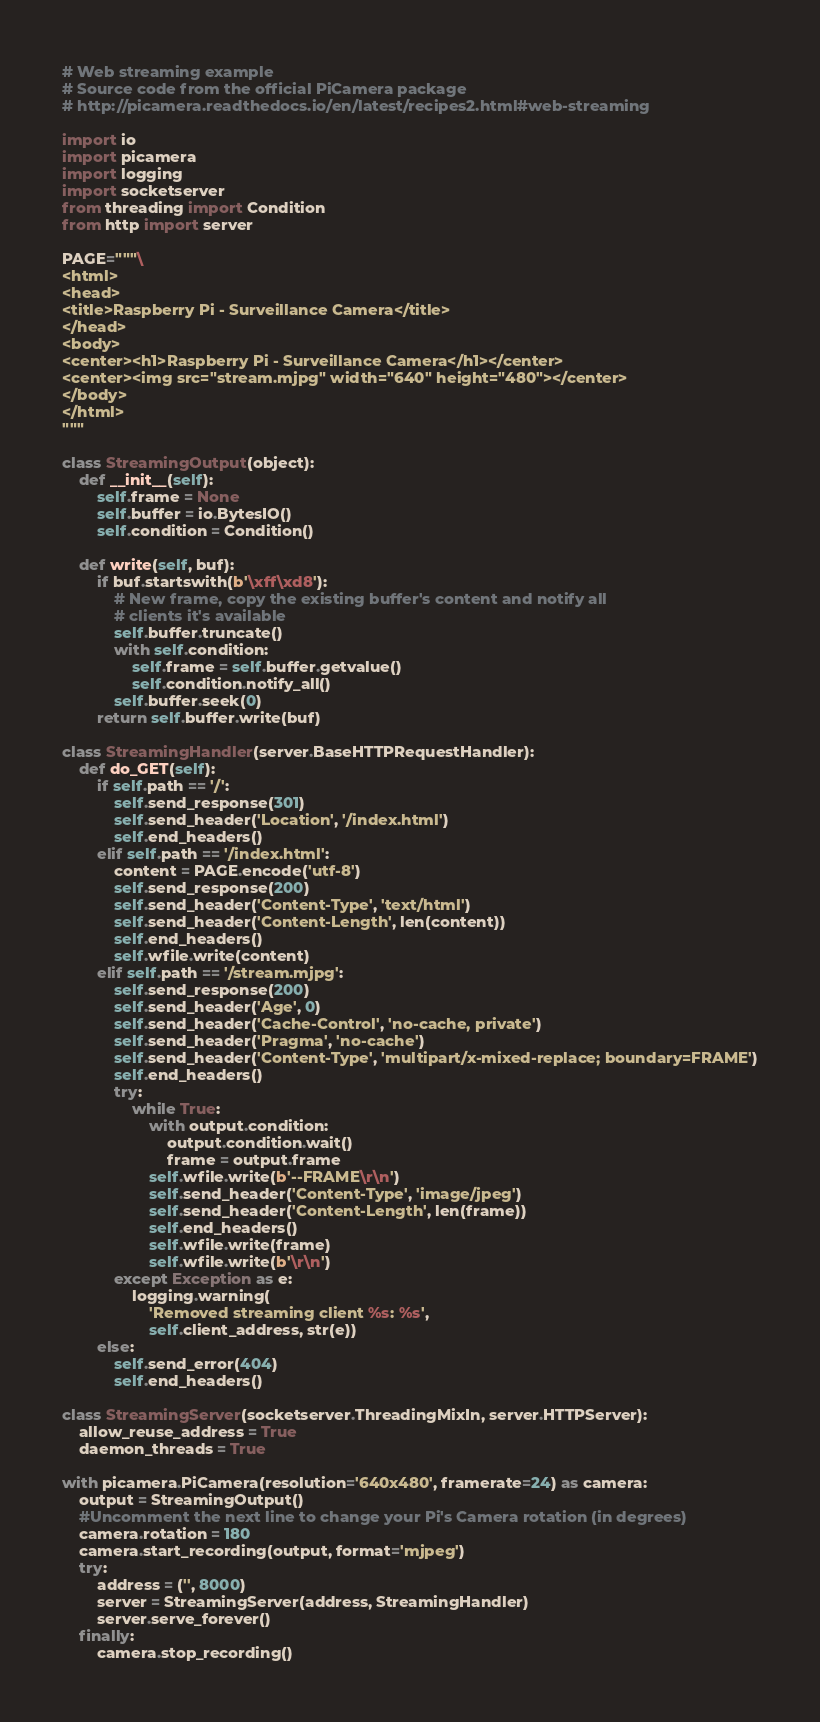Convert code to text. <code><loc_0><loc_0><loc_500><loc_500><_Python_># Web streaming example
# Source code from the official PiCamera package
# http://picamera.readthedocs.io/en/latest/recipes2.html#web-streaming

import io
import picamera
import logging
import socketserver
from threading import Condition
from http import server

PAGE="""\
<html>
<head>
<title>Raspberry Pi - Surveillance Camera</title>
</head>
<body>
<center><h1>Raspberry Pi - Surveillance Camera</h1></center>
<center><img src="stream.mjpg" width="640" height="480"></center>
</body>
</html>
"""

class StreamingOutput(object):
    def __init__(self):
        self.frame = None
        self.buffer = io.BytesIO()
        self.condition = Condition()

    def write(self, buf):
        if buf.startswith(b'\xff\xd8'):
            # New frame, copy the existing buffer's content and notify all
            # clients it's available
            self.buffer.truncate()
            with self.condition:
                self.frame = self.buffer.getvalue()
                self.condition.notify_all()
            self.buffer.seek(0)
        return self.buffer.write(buf)

class StreamingHandler(server.BaseHTTPRequestHandler):
    def do_GET(self):
        if self.path == '/':
            self.send_response(301)
            self.send_header('Location', '/index.html')
            self.end_headers()
        elif self.path == '/index.html':
            content = PAGE.encode('utf-8')
            self.send_response(200)
            self.send_header('Content-Type', 'text/html')
            self.send_header('Content-Length', len(content))
            self.end_headers()
            self.wfile.write(content)
        elif self.path == '/stream.mjpg':
            self.send_response(200)
            self.send_header('Age', 0)
            self.send_header('Cache-Control', 'no-cache, private')
            self.send_header('Pragma', 'no-cache')
            self.send_header('Content-Type', 'multipart/x-mixed-replace; boundary=FRAME')
            self.end_headers()
            try:
                while True:
                    with output.condition:
                        output.condition.wait()
                        frame = output.frame
                    self.wfile.write(b'--FRAME\r\n')
                    self.send_header('Content-Type', 'image/jpeg')
                    self.send_header('Content-Length', len(frame))
                    self.end_headers()
                    self.wfile.write(frame)
                    self.wfile.write(b'\r\n')
            except Exception as e:
                logging.warning(
                    'Removed streaming client %s: %s',
                    self.client_address, str(e))
        else:
            self.send_error(404)
            self.end_headers()

class StreamingServer(socketserver.ThreadingMixIn, server.HTTPServer):
    allow_reuse_address = True
    daemon_threads = True

with picamera.PiCamera(resolution='640x480', framerate=24) as camera:
    output = StreamingOutput()
    #Uncomment the next line to change your Pi's Camera rotation (in degrees)
    camera.rotation = 180
    camera.start_recording(output, format='mjpeg')
    try:
        address = ('', 8000)
        server = StreamingServer(address, StreamingHandler)
        server.serve_forever()
    finally:
        camera.stop_recording()
</code> 